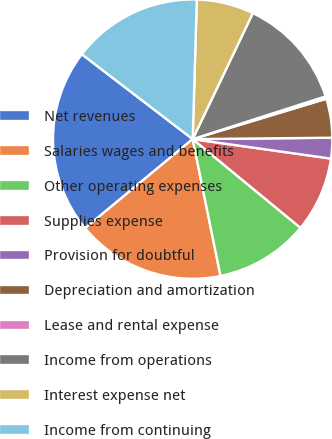Convert chart to OTSL. <chart><loc_0><loc_0><loc_500><loc_500><pie_chart><fcel>Net revenues<fcel>Salaries wages and benefits<fcel>Other operating expenses<fcel>Supplies expense<fcel>Provision for doubtful<fcel>Depreciation and amortization<fcel>Lease and rental expense<fcel>Income from operations<fcel>Interest expense net<fcel>Income from continuing<nl><fcel>21.41%<fcel>17.19%<fcel>10.85%<fcel>8.73%<fcel>2.39%<fcel>4.51%<fcel>0.28%<fcel>12.96%<fcel>6.62%<fcel>15.07%<nl></chart> 